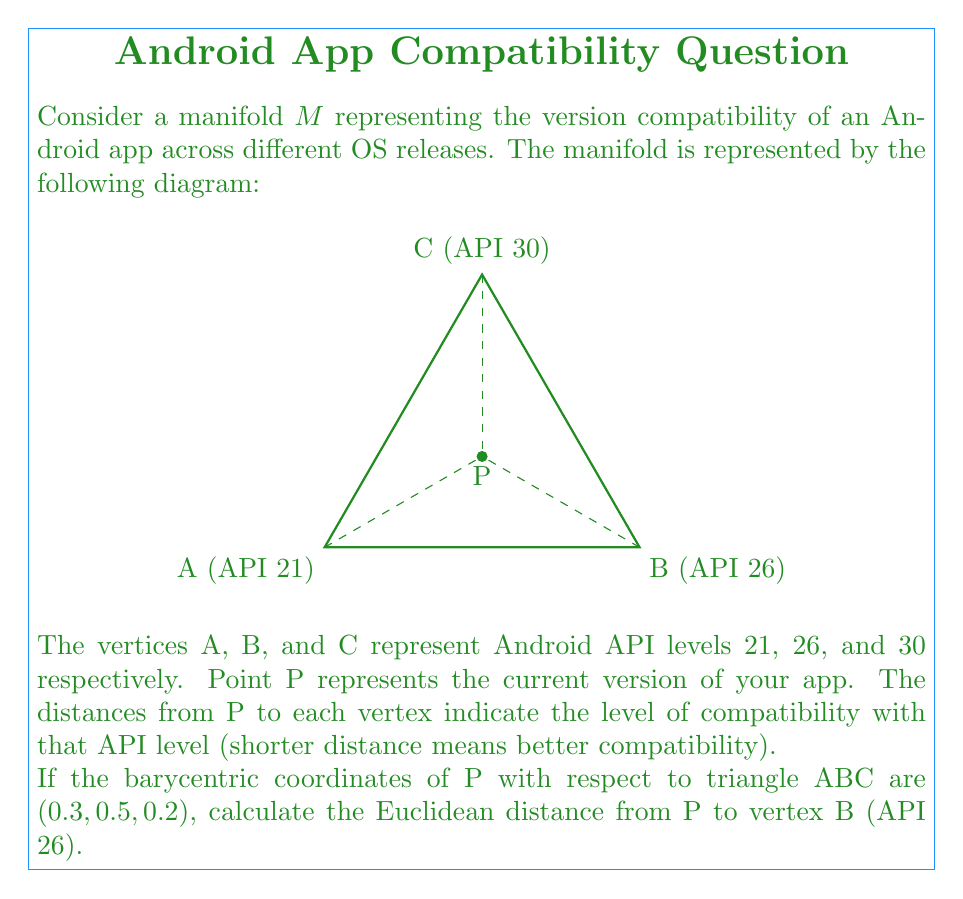Can you solve this math problem? Let's approach this step-by-step:

1) In a triangle, barycentric coordinates $(u, v, w)$ satisfy $u + v + w = 1$, where each coordinate represents the relative "closeness" to each vertex.

2) Given barycentric coordinates $(0.3, 0.5, 0.2)$, we know:
   $u = 0.3$ (weight for A)
   $v = 0.5$ (weight for B)
   $w = 0.2$ (weight for C)

3) In an equilateral triangle with side length 2 (as shown in the diagram), we can calculate the coordinates of the vertices:
   A: $(0, 0)$
   B: $(2, 0)$
   C: $(1, \sqrt{3})$

4) The coordinates of point P can be calculated using the barycentric coordinates:
   $P_x = 0.3 \cdot 0 + 0.5 \cdot 2 + 0.2 \cdot 1 = 1.2$
   $P_y = 0.3 \cdot 0 + 0.5 \cdot 0 + 0.2 \cdot \sqrt{3} = 0.2\sqrt{3}$

5) Now, we can calculate the Euclidean distance from P to B:
   $d = \sqrt{(P_x - B_x)^2 + (P_y - B_y)^2}$
   $d = \sqrt{(1.2 - 2)^2 + (0.2\sqrt{3} - 0)^2}$
   $d = \sqrt{0.8^2 + (0.2\sqrt{3})^2}$
   $d = \sqrt{0.64 + 0.12}$
   $d = \sqrt{0.76}$

6) Simplifying:
   $d = 2\sqrt{0.19} \approx 0.8718$

This distance represents the compatibility level of the app with API 26, where a shorter distance indicates better compatibility.
Answer: $2\sqrt{0.19}$ 